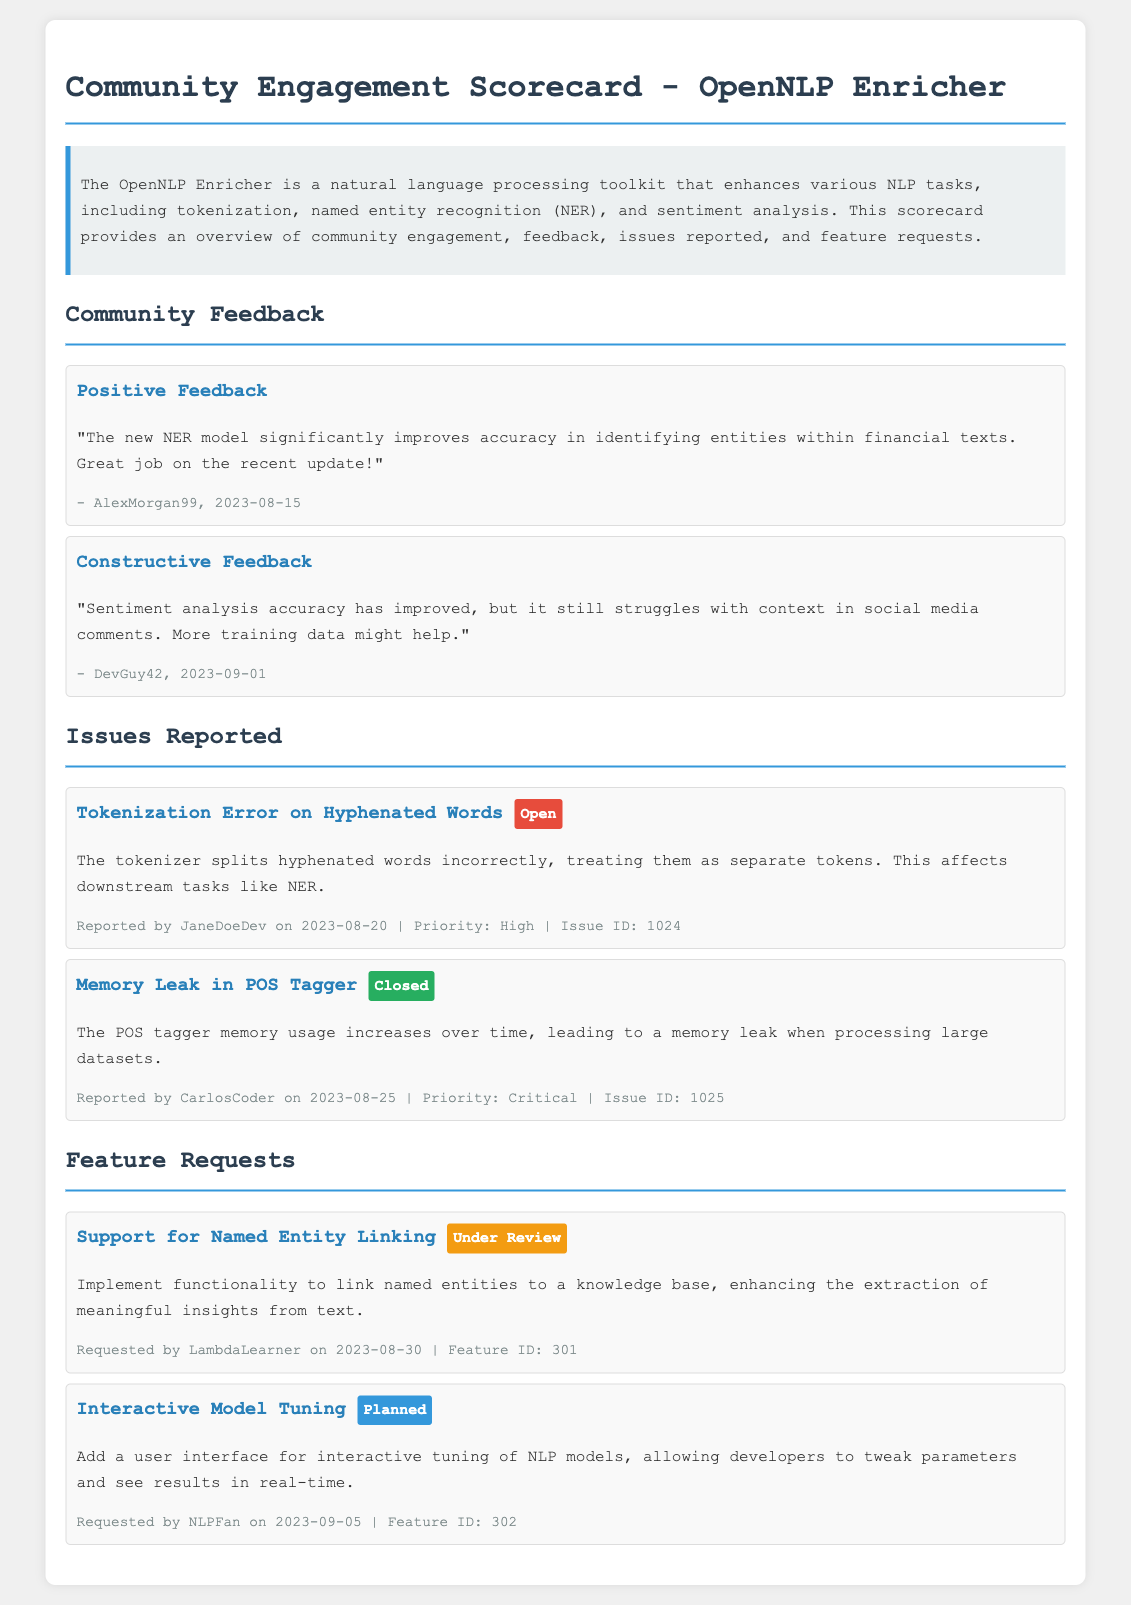what is the version of the toolkit mentioned in the scorecard? The scorecard refers to the "OpenNLP Enricher," which is a natural language processing toolkit.
Answer: OpenNLP Enricher who provided positive feedback? The feedback section mentions a user who provided positive feedback regarding the NER model.
Answer: AlexMorgan99 when was the tokenization error reported? The meta information in the issues reported section contains the date when the tokenization error was reported.
Answer: 2023-08-20 what is the status of the feature request for interactive model tuning? The current status of the interactive model tuning feature request is specified in the features section.
Answer: Planned what was the priority of the memory leak issue? The priority level for the memory leak issue in the POS tagger is noted in the issues reported section.
Answer: Critical how many feature requests are listed in the document? The features section outlines the total number of feature requests that have been documented.
Answer: 2 what is one reason for the constructive feedback on sentiment analysis? The constructive feedback section mentions a specific area in which the sentiment analysis tool struggles.
Answer: Context in social media comments who reported the issue regarding the tokenization error? The report of the tokenization error includes the name of the user who reported it.
Answer: JaneDoeDev 